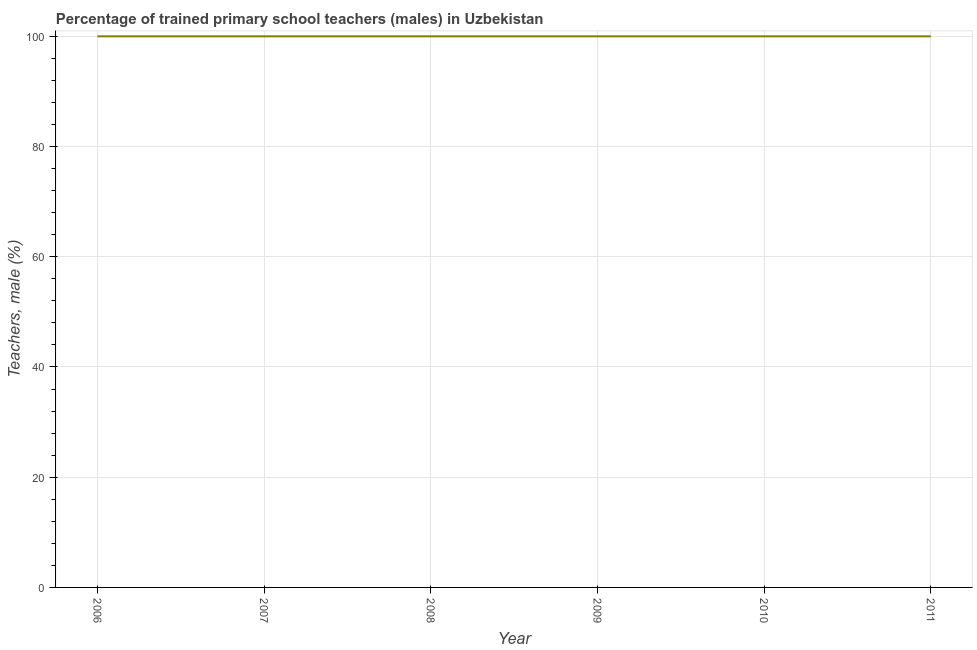What is the percentage of trained male teachers in 2009?
Give a very brief answer. 100. Across all years, what is the maximum percentage of trained male teachers?
Your answer should be compact. 100. Across all years, what is the minimum percentage of trained male teachers?
Your response must be concise. 100. In which year was the percentage of trained male teachers maximum?
Give a very brief answer. 2006. What is the sum of the percentage of trained male teachers?
Your answer should be compact. 600. What is the average percentage of trained male teachers per year?
Ensure brevity in your answer.  100. Do a majority of the years between 2009 and 2010 (inclusive) have percentage of trained male teachers greater than 48 %?
Keep it short and to the point. Yes. What is the ratio of the percentage of trained male teachers in 2009 to that in 2010?
Your response must be concise. 1. Is the percentage of trained male teachers in 2008 less than that in 2011?
Give a very brief answer. No. Is the difference between the percentage of trained male teachers in 2007 and 2011 greater than the difference between any two years?
Offer a terse response. Yes. What is the difference between the highest and the lowest percentage of trained male teachers?
Your answer should be compact. 0. Does the percentage of trained male teachers monotonically increase over the years?
Provide a succinct answer. No. How many lines are there?
Offer a very short reply. 1. How many years are there in the graph?
Offer a very short reply. 6. What is the difference between two consecutive major ticks on the Y-axis?
Give a very brief answer. 20. What is the title of the graph?
Provide a succinct answer. Percentage of trained primary school teachers (males) in Uzbekistan. What is the label or title of the X-axis?
Ensure brevity in your answer.  Year. What is the label or title of the Y-axis?
Give a very brief answer. Teachers, male (%). What is the Teachers, male (%) of 2008?
Your answer should be very brief. 100. What is the Teachers, male (%) in 2011?
Provide a succinct answer. 100. What is the difference between the Teachers, male (%) in 2006 and 2010?
Provide a short and direct response. 0. What is the difference between the Teachers, male (%) in 2007 and 2008?
Keep it short and to the point. 0. What is the difference between the Teachers, male (%) in 2007 and 2009?
Ensure brevity in your answer.  0. What is the difference between the Teachers, male (%) in 2007 and 2010?
Your answer should be compact. 0. What is the difference between the Teachers, male (%) in 2008 and 2010?
Offer a terse response. 0. What is the difference between the Teachers, male (%) in 2008 and 2011?
Give a very brief answer. 0. What is the difference between the Teachers, male (%) in 2009 and 2010?
Your response must be concise. 0. What is the ratio of the Teachers, male (%) in 2006 to that in 2008?
Offer a very short reply. 1. What is the ratio of the Teachers, male (%) in 2006 to that in 2009?
Give a very brief answer. 1. What is the ratio of the Teachers, male (%) in 2006 to that in 2011?
Provide a short and direct response. 1. What is the ratio of the Teachers, male (%) in 2007 to that in 2008?
Provide a short and direct response. 1. What is the ratio of the Teachers, male (%) in 2007 to that in 2010?
Your response must be concise. 1. What is the ratio of the Teachers, male (%) in 2008 to that in 2009?
Ensure brevity in your answer.  1. What is the ratio of the Teachers, male (%) in 2008 to that in 2010?
Ensure brevity in your answer.  1. 